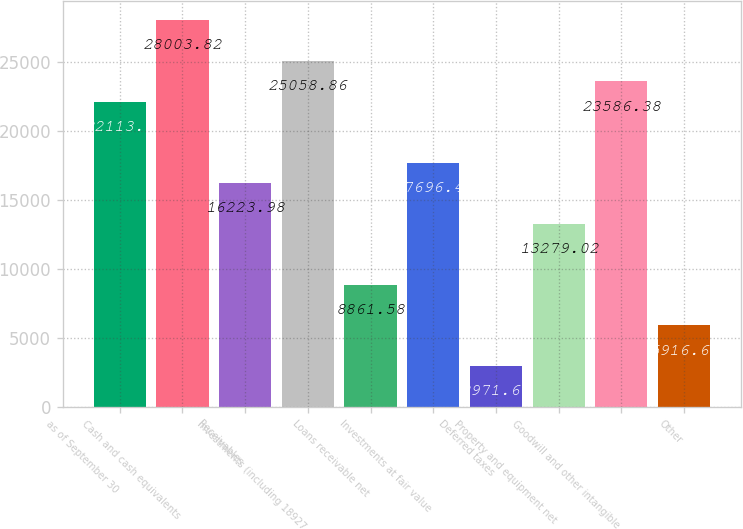Convert chart. <chart><loc_0><loc_0><loc_500><loc_500><bar_chart><fcel>as of September 30<fcel>Cash and cash equivalents<fcel>Receivables<fcel>Investments (including 18927<fcel>Loans receivable net<fcel>Investments at fair value<fcel>Deferred taxes<fcel>Property and equipment net<fcel>Goodwill and other intangible<fcel>Other<nl><fcel>22113.9<fcel>28003.8<fcel>16224<fcel>25058.9<fcel>8861.58<fcel>17696.5<fcel>2971.66<fcel>13279<fcel>23586.4<fcel>5916.62<nl></chart> 